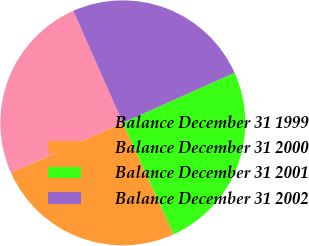Convert chart. <chart><loc_0><loc_0><loc_500><loc_500><pie_chart><fcel>Balance December 31 1999<fcel>Balance December 31 2000<fcel>Balance December 31 2001<fcel>Balance December 31 2002<nl><fcel>25.07%<fcel>25.1%<fcel>24.91%<fcel>24.93%<nl></chart> 